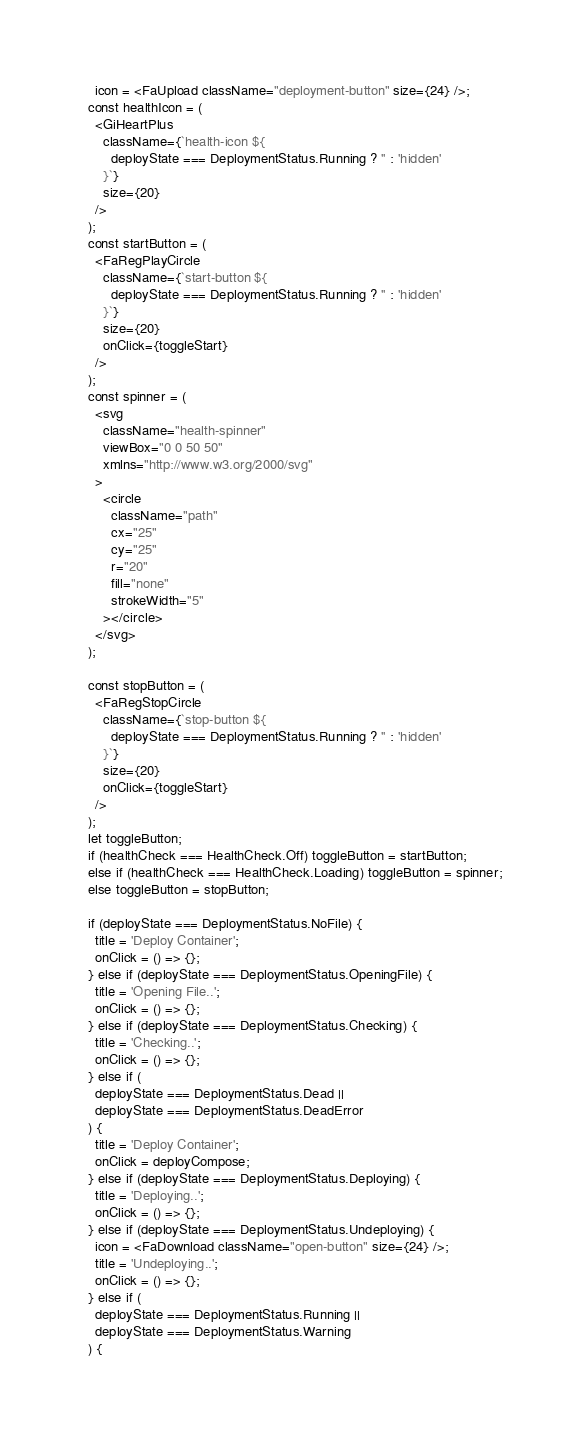Convert code to text. <code><loc_0><loc_0><loc_500><loc_500><_TypeScript_>    icon = <FaUpload className="deployment-button" size={24} />;
  const healthIcon = (
    <GiHeartPlus
      className={`health-icon ${
        deployState === DeploymentStatus.Running ? '' : 'hidden'
      }`}
      size={20}
    />
  );
  const startButton = (
    <FaRegPlayCircle
      className={`start-button ${
        deployState === DeploymentStatus.Running ? '' : 'hidden'
      }`}
      size={20}
      onClick={toggleStart}
    />
  );
  const spinner = (
    <svg
      className="health-spinner"
      viewBox="0 0 50 50"
      xmlns="http://www.w3.org/2000/svg"
    >
      <circle
        className="path"
        cx="25"
        cy="25"
        r="20"
        fill="none"
        strokeWidth="5"
      ></circle>
    </svg>
  );

  const stopButton = (
    <FaRegStopCircle
      className={`stop-button ${
        deployState === DeploymentStatus.Running ? '' : 'hidden'
      }`}
      size={20}
      onClick={toggleStart}
    />
  );
  let toggleButton;
  if (healthCheck === HealthCheck.Off) toggleButton = startButton;
  else if (healthCheck === HealthCheck.Loading) toggleButton = spinner;
  else toggleButton = stopButton;

  if (deployState === DeploymentStatus.NoFile) {
    title = 'Deploy Container';
    onClick = () => {};
  } else if (deployState === DeploymentStatus.OpeningFile) {
    title = 'Opening File..';
    onClick = () => {};
  } else if (deployState === DeploymentStatus.Checking) {
    title = 'Checking..';
    onClick = () => {};
  } else if (
    deployState === DeploymentStatus.Dead ||
    deployState === DeploymentStatus.DeadError
  ) {
    title = 'Deploy Container';
    onClick = deployCompose;
  } else if (deployState === DeploymentStatus.Deploying) {
    title = 'Deploying..';
    onClick = () => {};
  } else if (deployState === DeploymentStatus.Undeploying) {
    icon = <FaDownload className="open-button" size={24} />;
    title = 'Undeploying..';
    onClick = () => {};
  } else if (
    deployState === DeploymentStatus.Running ||
    deployState === DeploymentStatus.Warning
  ) {</code> 